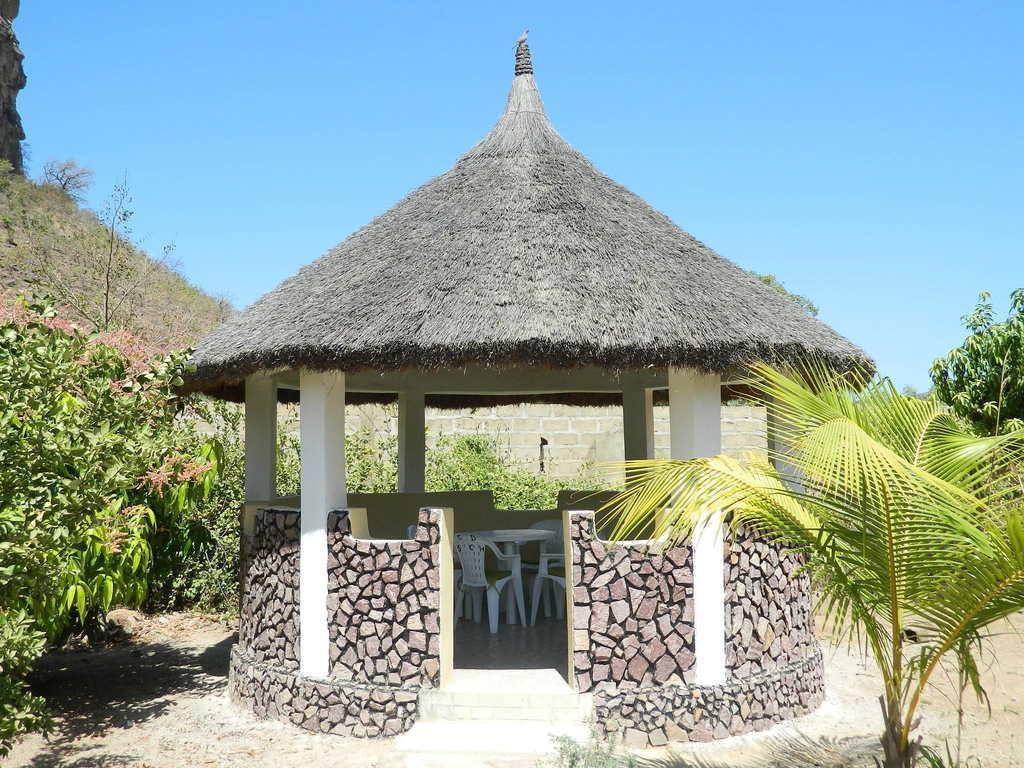How would you summarize this image in a sentence or two? In this image we can see thatched house and chairs in it. In the background we can see trees, hills, ground and sky. 